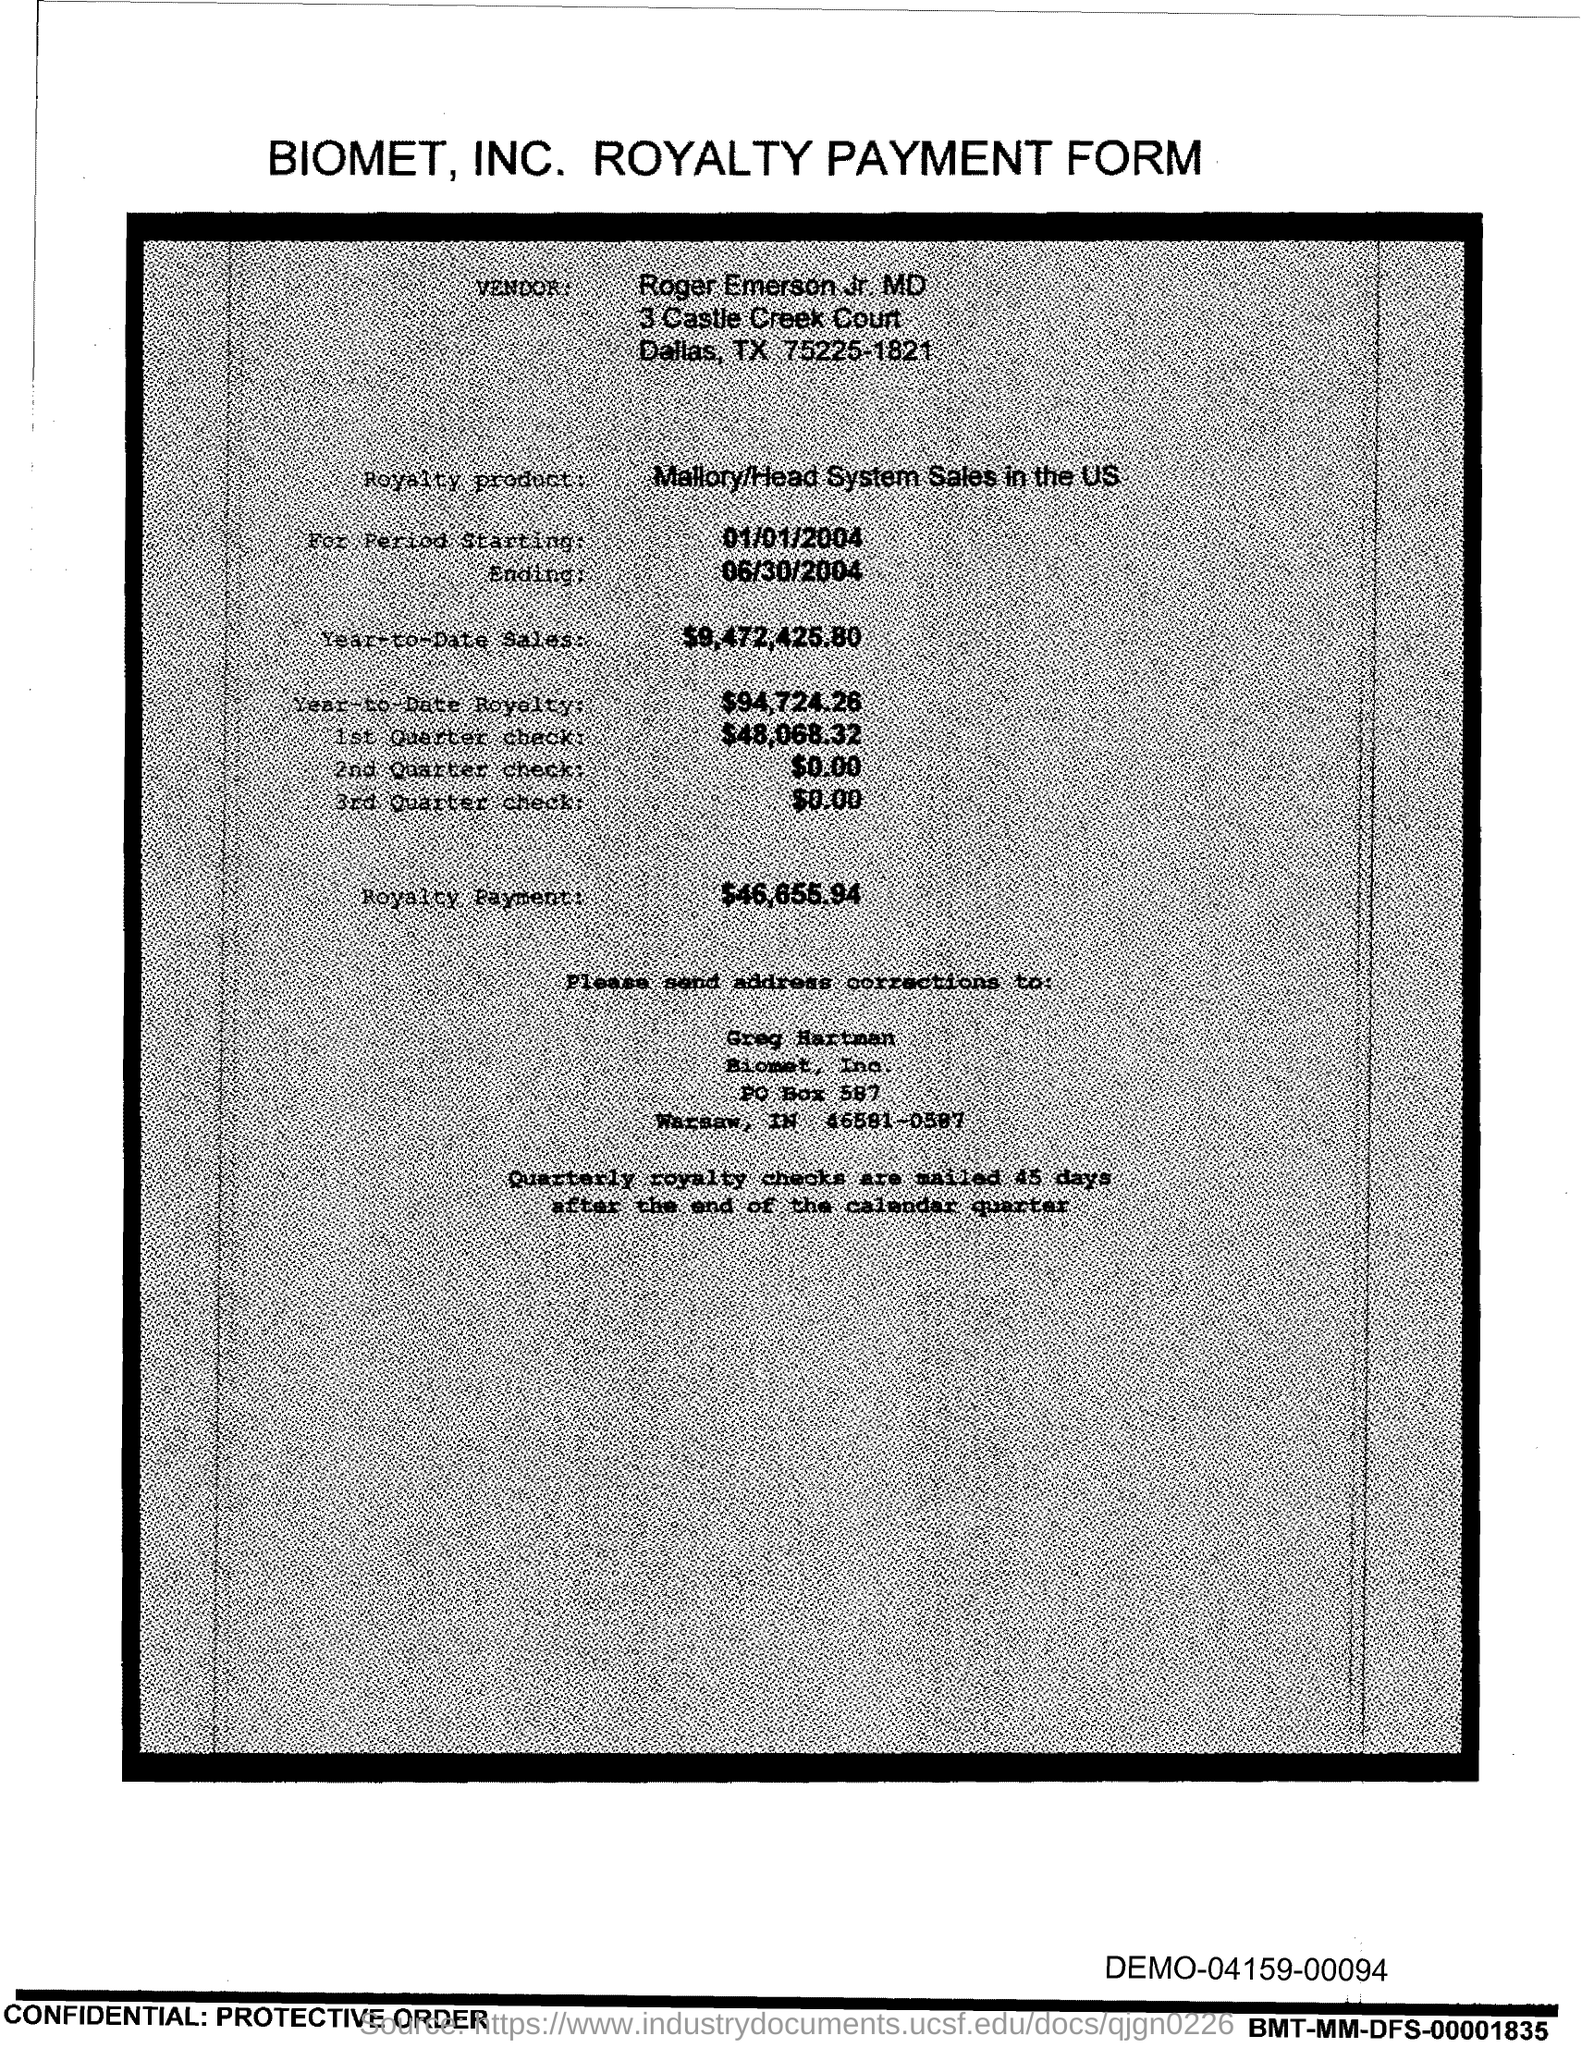What is the Year-to-Date-Sales?
Give a very brief answer. $9,472,425.80. 